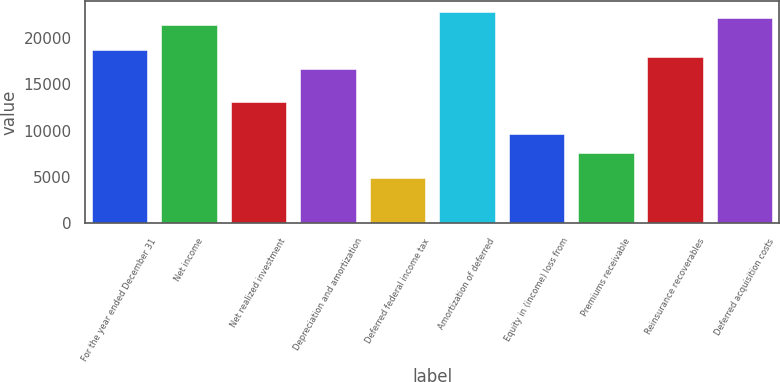Convert chart to OTSL. <chart><loc_0><loc_0><loc_500><loc_500><bar_chart><fcel>For the year ended December 31<fcel>Net income<fcel>Net realized investment<fcel>Depreciation and amortization<fcel>Deferred federal income tax<fcel>Amortization of deferred<fcel>Equity in (income) loss from<fcel>Premiums receivable<fcel>Reinsurance recoverables<fcel>Deferred acquisition costs<nl><fcel>18699.4<fcel>21468.2<fcel>13161.8<fcel>16622.8<fcel>4855.4<fcel>22852.6<fcel>9700.8<fcel>7624.2<fcel>18007.2<fcel>22160.4<nl></chart> 